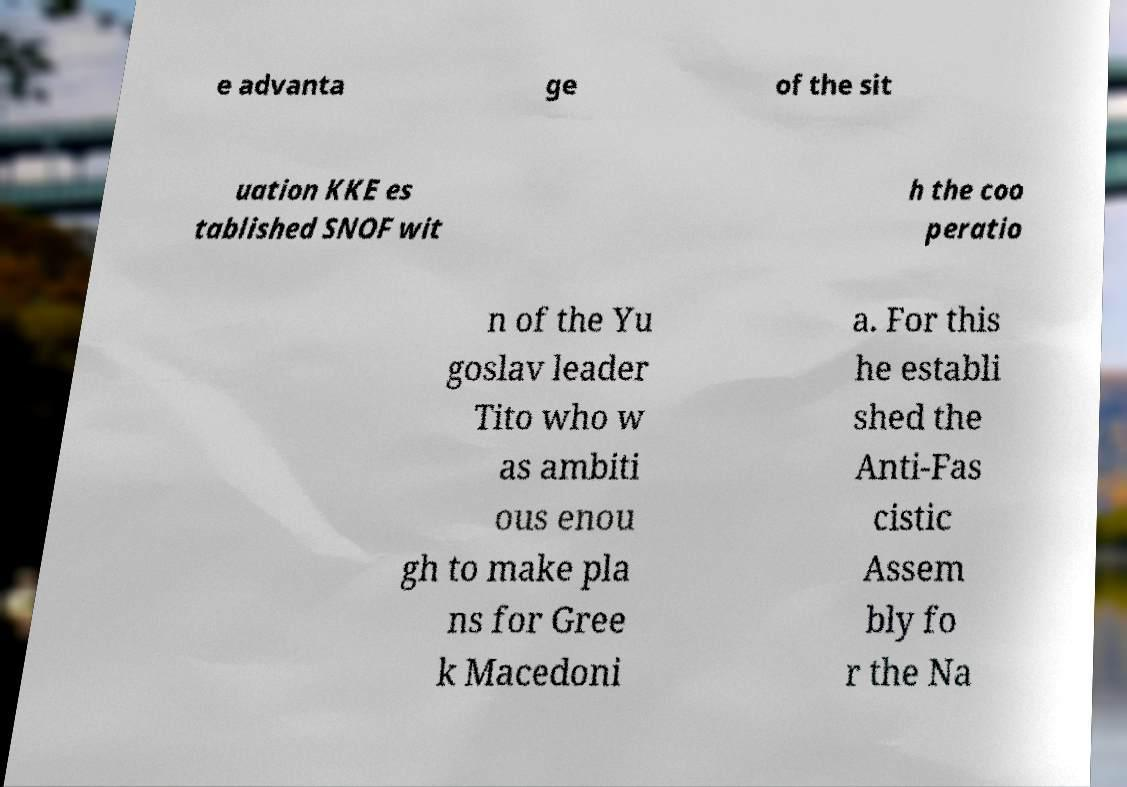Can you accurately transcribe the text from the provided image for me? e advanta ge of the sit uation KKE es tablished SNOF wit h the coo peratio n of the Yu goslav leader Tito who w as ambiti ous enou gh to make pla ns for Gree k Macedoni a. For this he establi shed the Anti-Fas cistic Assem bly fo r the Na 